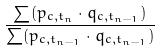<formula> <loc_0><loc_0><loc_500><loc_500>\frac { \sum ( p _ { c , t _ { n } } \cdot q _ { c , t _ { n - 1 } } ) } { \sum ( p _ { c , t _ { n - 1 } } \cdot q _ { c , t _ { n - 1 } } ) }</formula> 